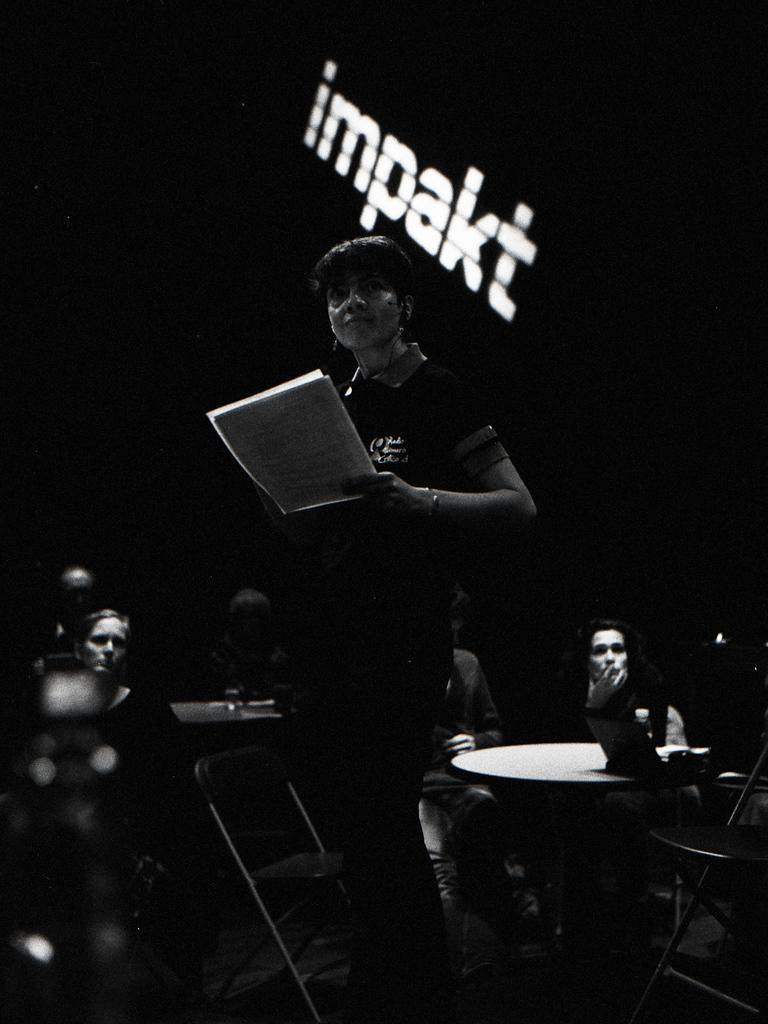What is the color scheme of the image? The image is black and white. What is the woman in the image doing? The woman is standing and holding papers in her hands. What are the people in the image doing? The people are sitting. What furniture is present in the image? Chairs and tables are present in the image. What type of flame can be seen on the table in the image? There is no flame present in the image; it is a black and white image with a woman standing and holding papers, people sitting, and chairs and tables as furniture. What type of fork is being used by the woman in the image? There is no fork present in the image; the woman is holding papers in her hands. 